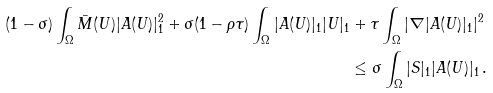<formula> <loc_0><loc_0><loc_500><loc_500>( 1 - \sigma ) \int _ { \Omega } \bar { M } ( U ) | A ( U ) | _ { 1 } ^ { 2 } + \sigma ( 1 - \rho \tau ) \int _ { \Omega } | A ( U ) | _ { 1 } | U | _ { 1 } & + \tau \int _ { \Omega } | \nabla | A ( U ) | _ { 1 } | ^ { 2 } \\ & \leq \sigma \int _ { \Omega } | S | _ { 1 } | A ( U ) | _ { 1 } \, .</formula> 